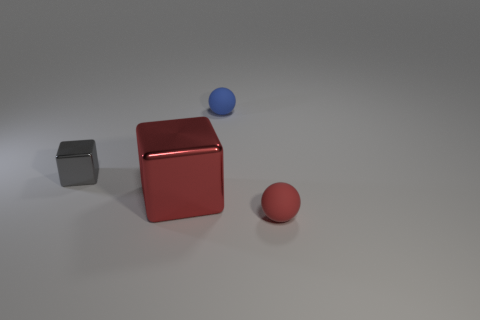What number of tiny objects have the same color as the large thing?
Your answer should be compact. 1. There is a tiny sphere in front of the big metallic block; is its color the same as the large thing?
Give a very brief answer. Yes. What number of other things are there of the same size as the red shiny block?
Your answer should be very brief. 0. There is a matte object that is in front of the tiny shiny cube; is it the same color as the cube to the right of the gray metallic block?
Your answer should be compact. Yes. What is the size of the red metal thing that is the same shape as the small gray metallic thing?
Your answer should be very brief. Large. Do the sphere that is in front of the blue sphere and the blue object that is behind the big red metal thing have the same material?
Offer a terse response. Yes. What number of rubber things are small red balls or blue things?
Provide a succinct answer. 2. There is a tiny red object right of the metal object on the left side of the metallic thing right of the tiny gray block; what is it made of?
Your response must be concise. Rubber. Do the red object on the left side of the blue matte sphere and the small object on the left side of the tiny blue rubber ball have the same shape?
Your response must be concise. Yes. What color is the tiny rubber thing on the left side of the tiny sphere that is in front of the blue object?
Your answer should be very brief. Blue. 